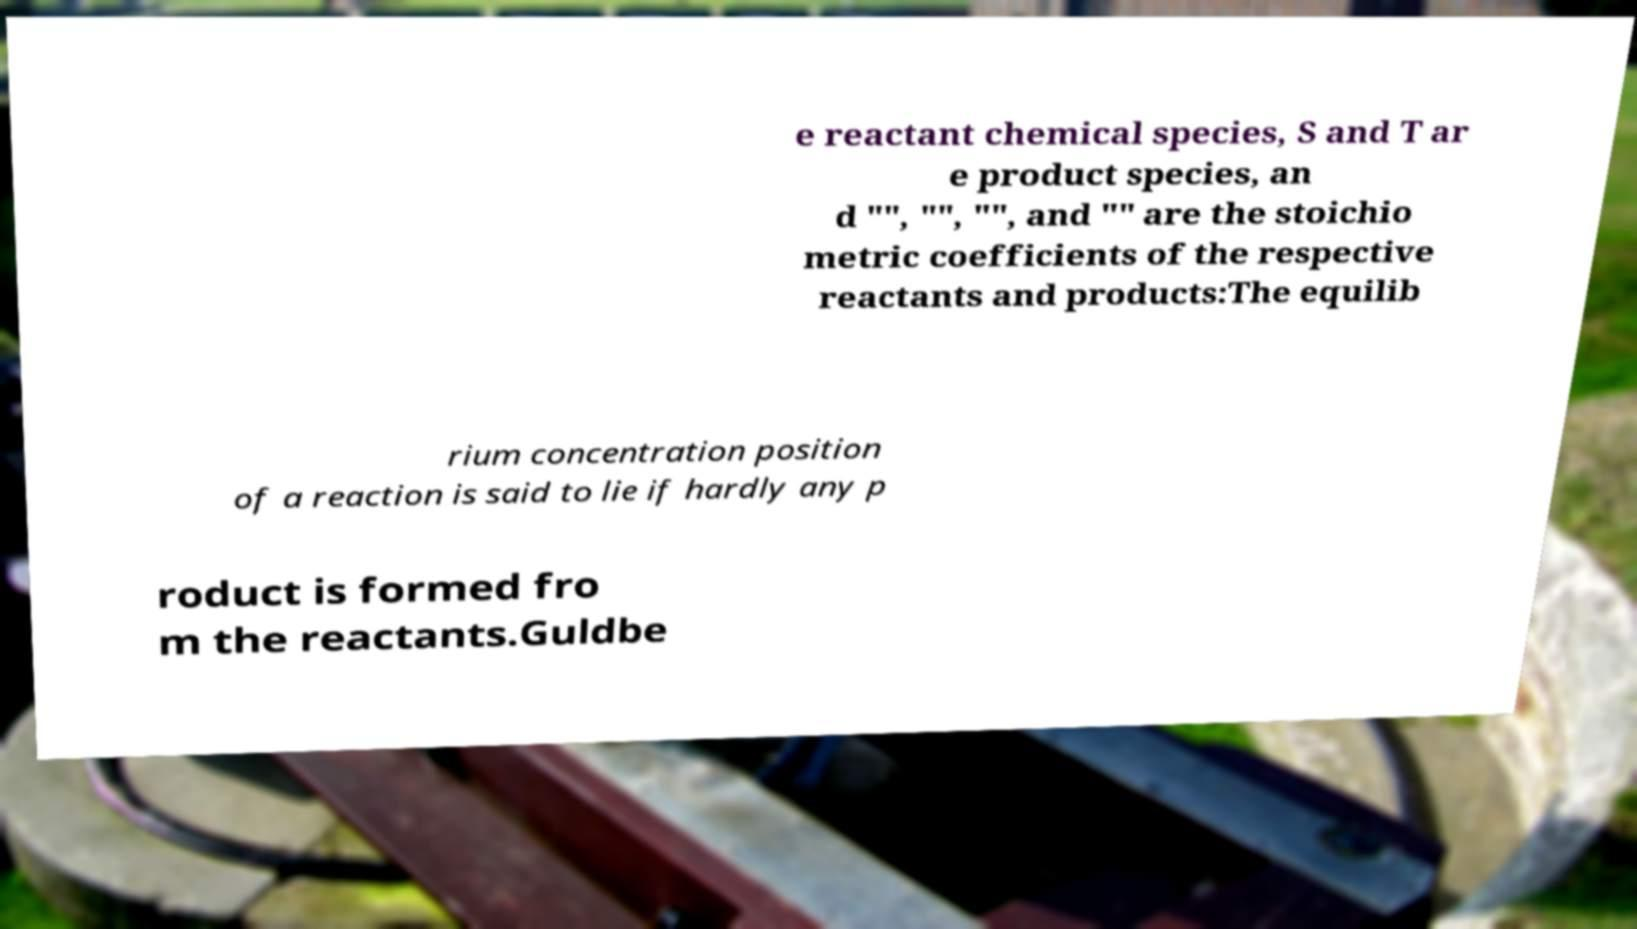There's text embedded in this image that I need extracted. Can you transcribe it verbatim? e reactant chemical species, S and T ar e product species, an d "", "", "", and "" are the stoichio metric coefficients of the respective reactants and products:The equilib rium concentration position of a reaction is said to lie if hardly any p roduct is formed fro m the reactants.Guldbe 